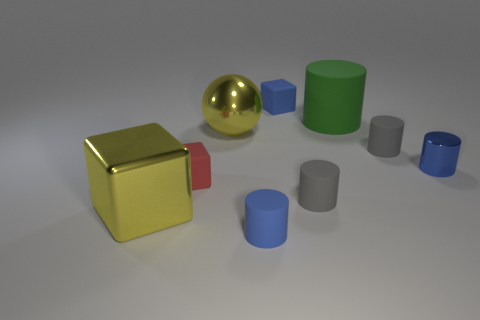Subtract all blue cubes. How many cubes are left? 2 Subtract all gray balls. How many gray cylinders are left? 2 Subtract all blue cylinders. How many cylinders are left? 3 Subtract all yellow cylinders. Subtract all brown balls. How many cylinders are left? 5 Add 1 small green metal cylinders. How many objects exist? 10 Subtract all cylinders. How many objects are left? 4 Add 2 yellow metal cubes. How many yellow metal cubes exist? 3 Subtract 1 blue blocks. How many objects are left? 8 Subtract all large yellow metal balls. Subtract all big things. How many objects are left? 5 Add 3 big green matte cylinders. How many big green matte cylinders are left? 4 